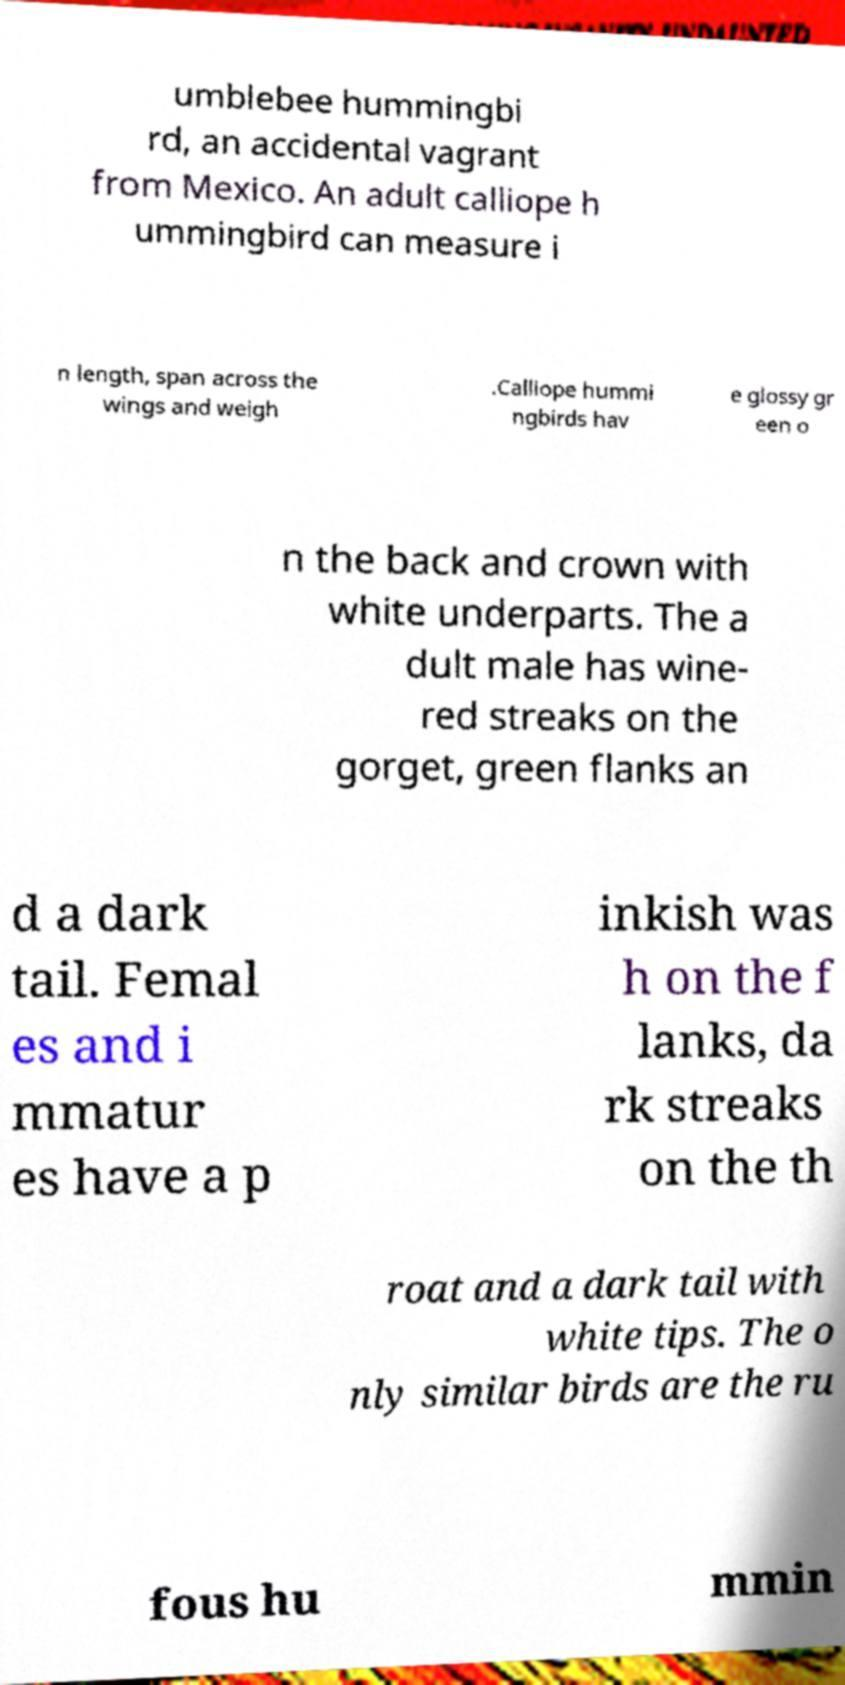For documentation purposes, I need the text within this image transcribed. Could you provide that? umblebee hummingbi rd, an accidental vagrant from Mexico. An adult calliope h ummingbird can measure i n length, span across the wings and weigh .Calliope hummi ngbirds hav e glossy gr een o n the back and crown with white underparts. The a dult male has wine- red streaks on the gorget, green flanks an d a dark tail. Femal es and i mmatur es have a p inkish was h on the f lanks, da rk streaks on the th roat and a dark tail with white tips. The o nly similar birds are the ru fous hu mmin 